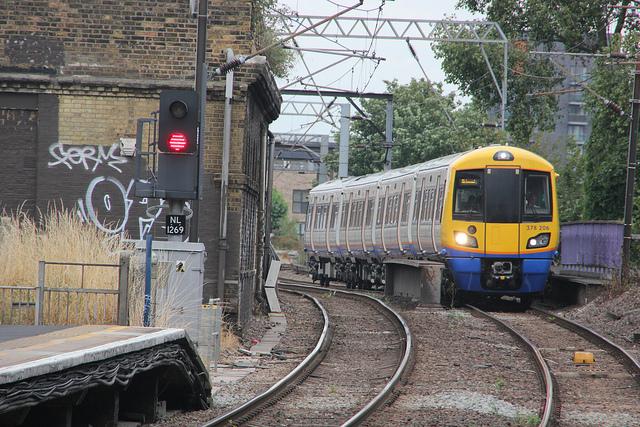What is the train on?
Write a very short answer. Tracks. Is there any graffiti on the building?
Write a very short answer. Yes. What color is the stoplight on?
Quick response, please. Red. 